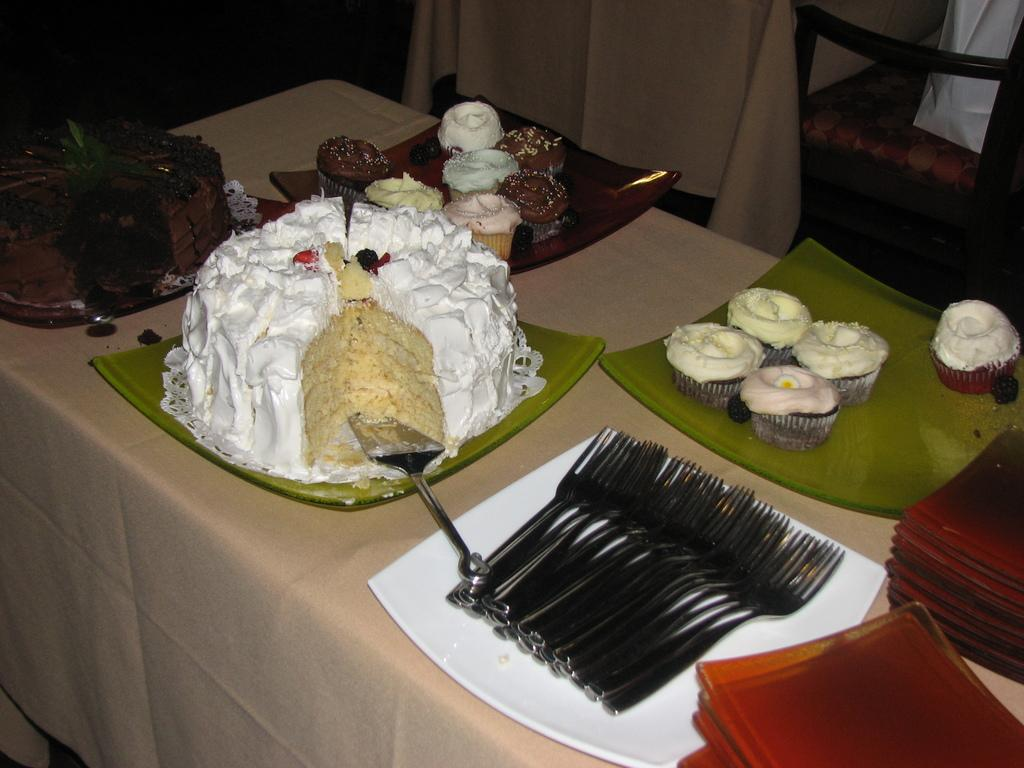What type of food items can be seen in the image? There are cakes and cupcakes in the image. What utensils are present in the image? There are spoons in the image. What are the cakes, spoons, and cupcakes placed on? There are plates in the image. What colors are the cakes, spoons, plates, and cupcakes? The cakes, spoons, plates, and cupcakes are in white, cream, and brown colors. What type of suit is hanging on the wall in the image? There is no suit present in the image; it features cakes, spoons, plates, and cupcakes. What ornament is placed on top of the cupcakes in the image? There are no ornaments placed on top of the cupcakes in the image. 